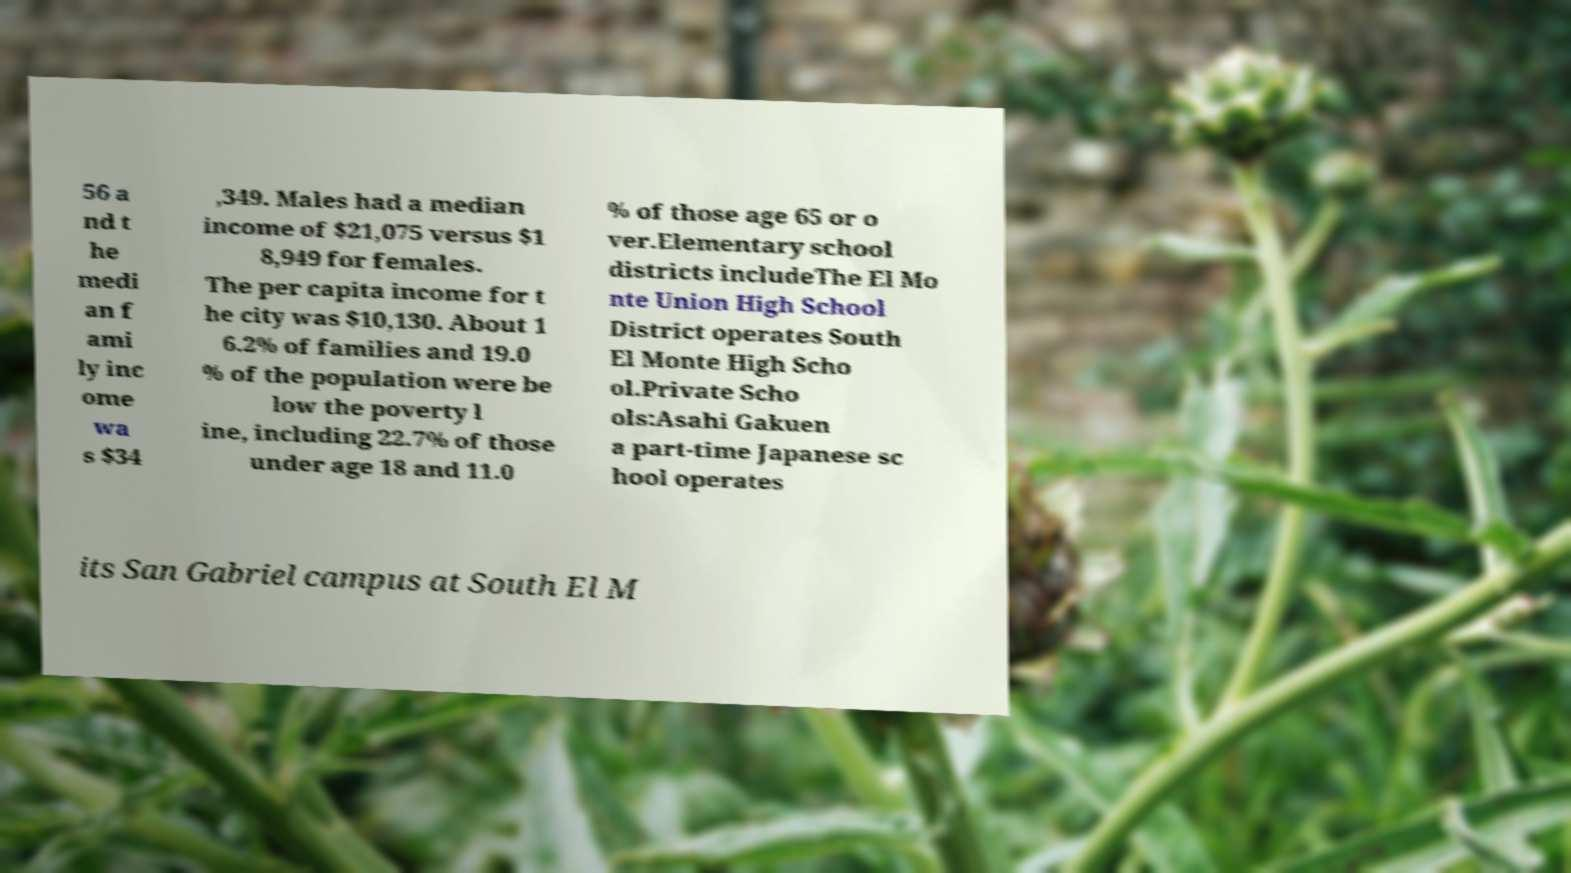I need the written content from this picture converted into text. Can you do that? 56 a nd t he medi an f ami ly inc ome wa s $34 ,349. Males had a median income of $21,075 versus $1 8,949 for females. The per capita income for t he city was $10,130. About 1 6.2% of families and 19.0 % of the population were be low the poverty l ine, including 22.7% of those under age 18 and 11.0 % of those age 65 or o ver.Elementary school districts includeThe El Mo nte Union High School District operates South El Monte High Scho ol.Private Scho ols:Asahi Gakuen a part-time Japanese sc hool operates its San Gabriel campus at South El M 